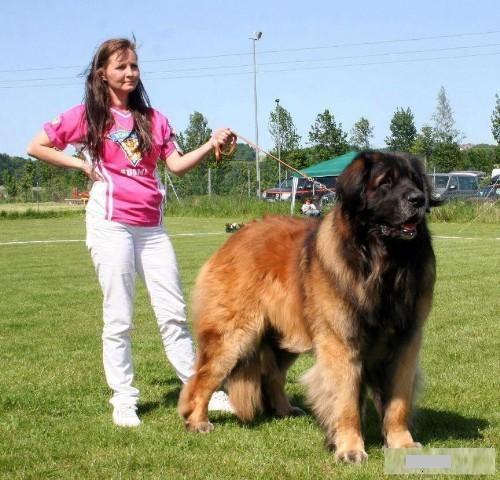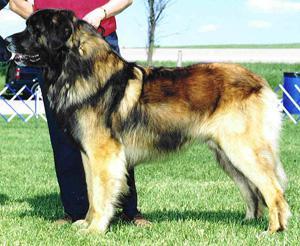The first image is the image on the left, the second image is the image on the right. For the images displayed, is the sentence "A child wearing a red jacket is with a dog." factually correct? Answer yes or no. No. 